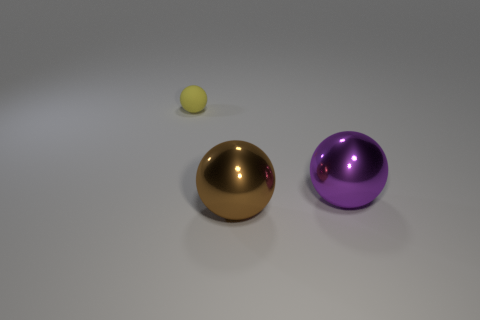The large thing behind the large sphere that is left of the purple object is what shape?
Provide a short and direct response. Sphere. Is there any other thing that is the same color as the tiny sphere?
Provide a short and direct response. No. Is there any other thing that is the same size as the purple shiny sphere?
Give a very brief answer. Yes. How many objects are either large brown balls or big blue metallic blocks?
Ensure brevity in your answer.  1. Are there any purple rubber balls of the same size as the brown ball?
Offer a terse response. No. What is the shape of the purple object?
Provide a succinct answer. Sphere. Is the number of matte objects in front of the matte thing greater than the number of metal objects that are in front of the large brown thing?
Offer a terse response. No. There is a metal thing in front of the big purple sphere; is it the same color as the sphere behind the purple ball?
Keep it short and to the point. No. There is a metallic thing that is the same size as the brown ball; what shape is it?
Your answer should be very brief. Sphere. Are there any large brown metallic objects that have the same shape as the big purple shiny thing?
Give a very brief answer. Yes. 